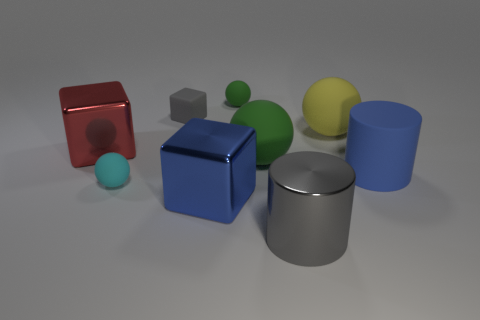Subtract all small gray matte blocks. How many blocks are left? 2 Subtract all yellow cubes. How many green spheres are left? 2 Subtract all gray blocks. Subtract all cyan objects. How many objects are left? 7 Add 6 blue cylinders. How many blue cylinders are left? 7 Add 4 yellow matte balls. How many yellow matte balls exist? 5 Subtract all cyan spheres. How many spheres are left? 3 Subtract 0 red cylinders. How many objects are left? 9 Subtract all cylinders. How many objects are left? 7 Subtract 4 spheres. How many spheres are left? 0 Subtract all green cylinders. Subtract all cyan spheres. How many cylinders are left? 2 